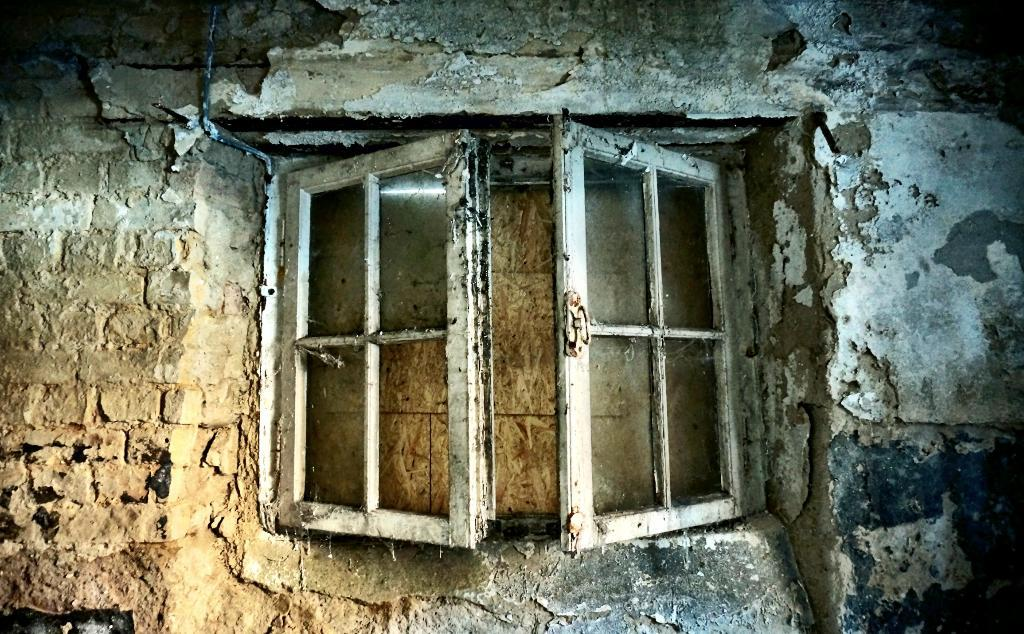What is the focus of the image? The image is a zoomed in view. What can be seen in the zoomed in view? There is an old window in the image. What else is visible in the image? There is a wall in the image. How many girls are controlling the worm in the image? There are no girls or worms present in the image. 